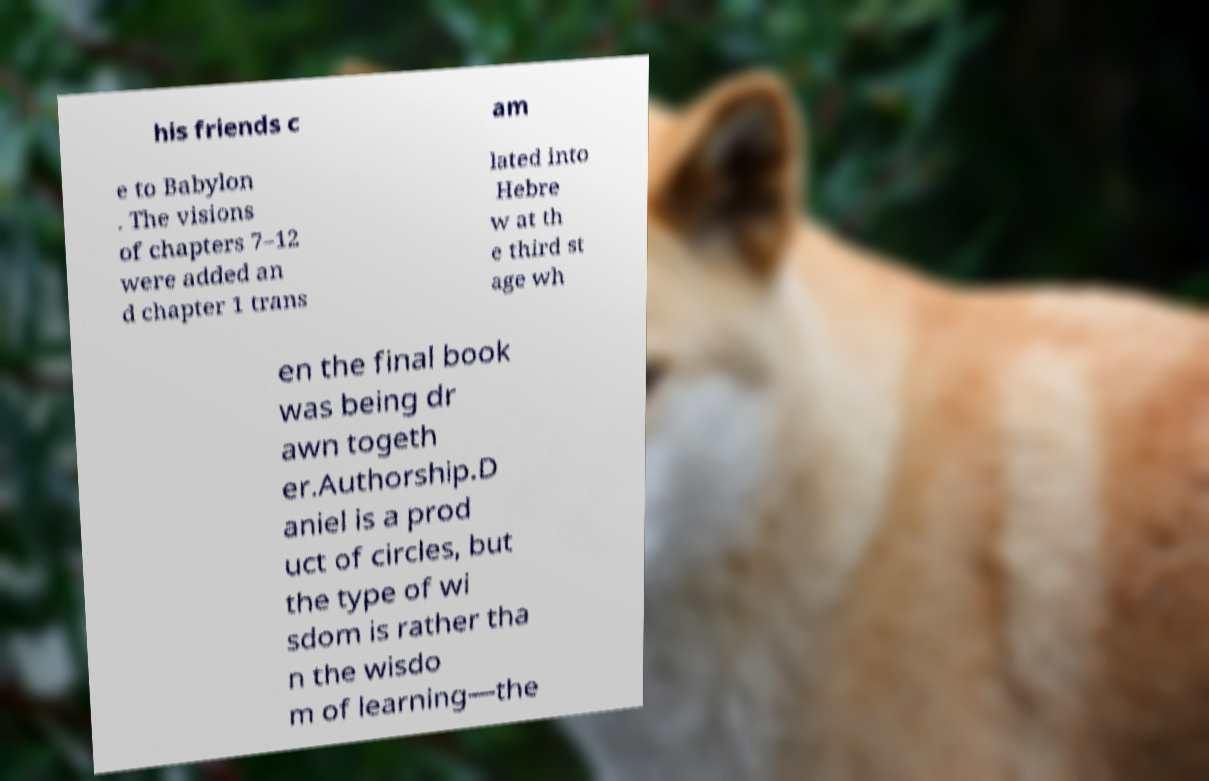Could you assist in decoding the text presented in this image and type it out clearly? his friends c am e to Babylon . The visions of chapters 7–12 were added an d chapter 1 trans lated into Hebre w at th e third st age wh en the final book was being dr awn togeth er.Authorship.D aniel is a prod uct of circles, but the type of wi sdom is rather tha n the wisdo m of learning—the 